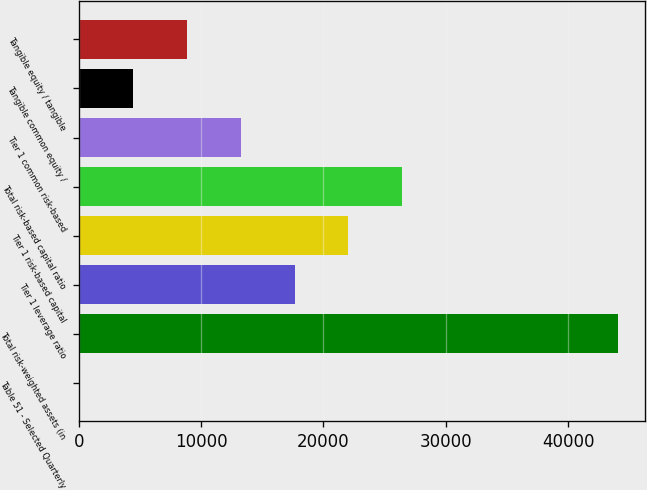Convert chart. <chart><loc_0><loc_0><loc_500><loc_500><bar_chart><fcel>Table 51 - Selected Quarterly<fcel>Total risk-weighted assets (in<fcel>Tier 1 leverage ratio<fcel>Tier 1 risk-based capital<fcel>Total risk-based capital ratio<fcel>Tier 1 common risk-based<fcel>Tangible common equity /<fcel>Tangible equity / tangible<nl><fcel>1<fcel>44080<fcel>17632.6<fcel>22040.5<fcel>26448.4<fcel>13224.7<fcel>4408.9<fcel>8816.8<nl></chart> 